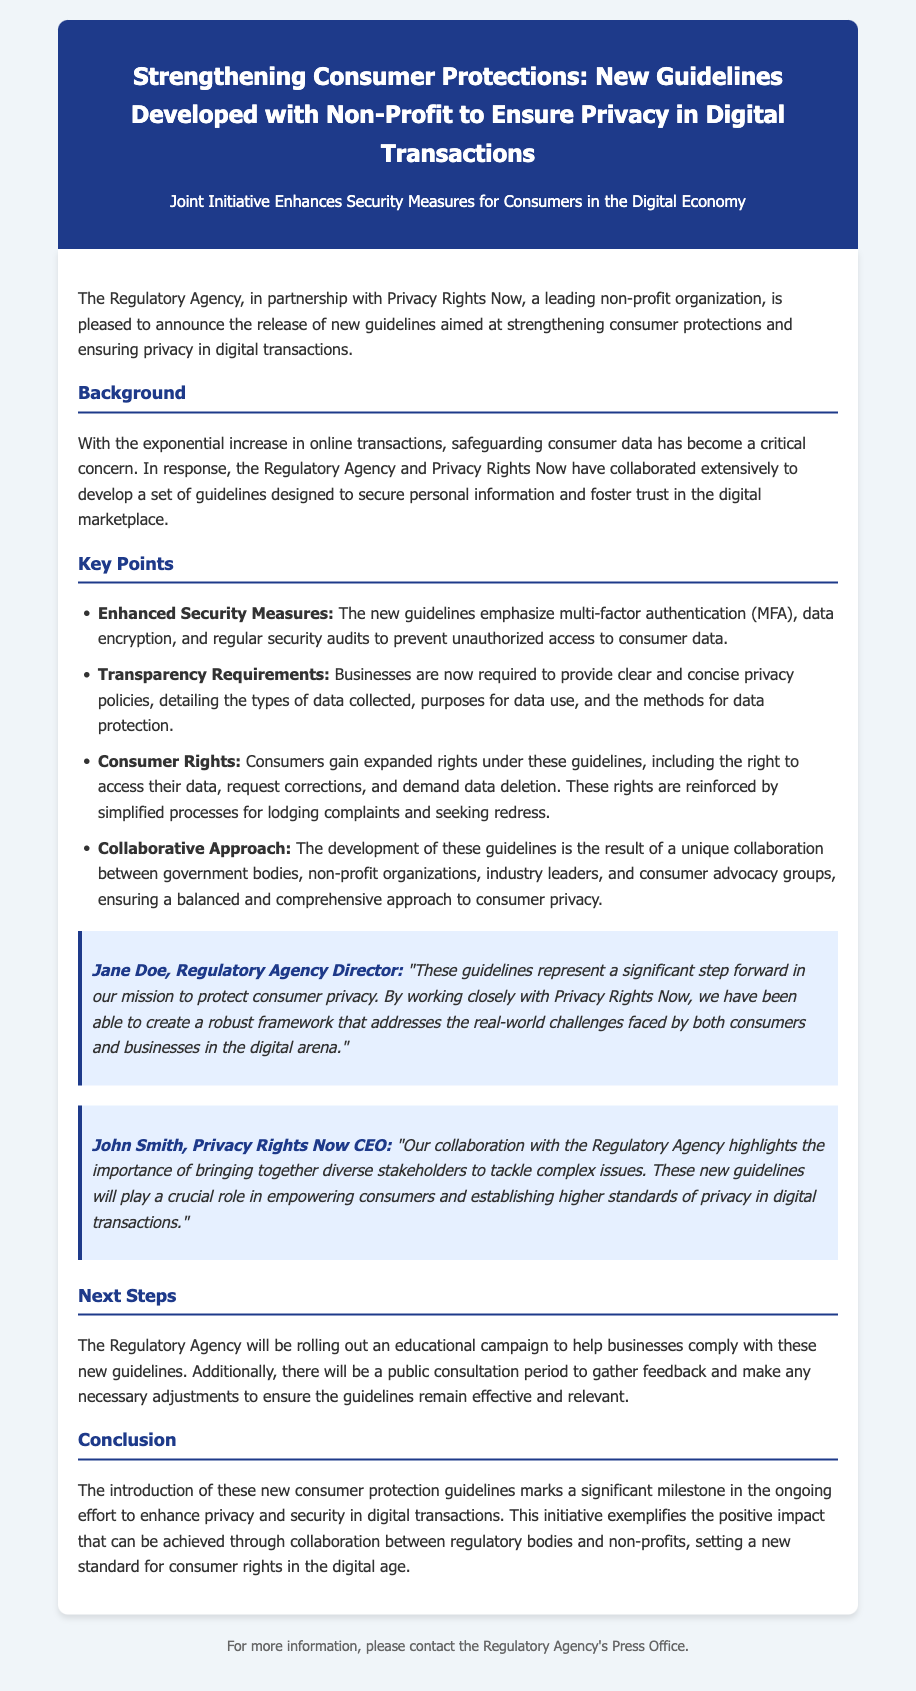What organization partnered with the Regulatory Agency? The document states that the Regulatory Agency partnered with Privacy Rights Now, a leading non-profit organization.
Answer: Privacy Rights Now What do the new guidelines emphasize? The document highlights that the new guidelines emphasize multi-factor authentication, data encryption, and regular security audits.
Answer: Enhanced Security Measures What rights do consumers gain under the new guidelines? The document mentions that consumers gain expanded rights including access to their data, request corrections, and demand data deletion.
Answer: Expanded rights Who is the CEO of Privacy Rights Now? The document identifies John Smith as the CEO of Privacy Rights Now.
Answer: John Smith What will the Regulatory Agency roll out to help businesses? According to the document, the Regulatory Agency will roll out an educational campaign to help businesses comply with the new guidelines.
Answer: Educational campaign What is the purpose of the public consultation period mentioned in the document? The public consultation period aims to gather feedback and make necessary adjustments to ensure the guidelines remain effective and relevant.
Answer: Gather feedback What is a primary goal of these new guidelines? The document suggests that a primary goal of the guidelines is to protect consumer privacy.
Answer: Protect consumer privacy When was the press release issued? The document does not provide a specific date for the press release issue.
Answer: Not specified 